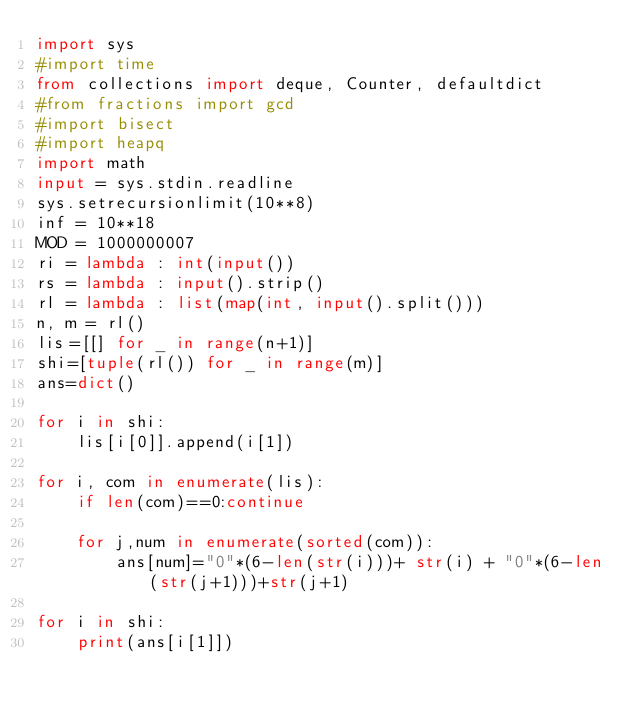Convert code to text. <code><loc_0><loc_0><loc_500><loc_500><_Python_>import sys
#import time
from collections import deque, Counter, defaultdict
#from fractions import gcd
#import bisect
#import heapq
import math
input = sys.stdin.readline
sys.setrecursionlimit(10**8)
inf = 10**18
MOD = 1000000007
ri = lambda : int(input())
rs = lambda : input().strip()
rl = lambda : list(map(int, input().split()))
n, m = rl()
lis=[[] for _ in range(n+1)]
shi=[tuple(rl()) for _ in range(m)]
ans=dict()

for i in shi:
    lis[i[0]].append(i[1])

for i, com in enumerate(lis):
    if len(com)==0:continue

    for j,num in enumerate(sorted(com)):
        ans[num]="0"*(6-len(str(i)))+ str(i) + "0"*(6-len(str(j+1)))+str(j+1)

for i in shi:
    print(ans[i[1]])</code> 